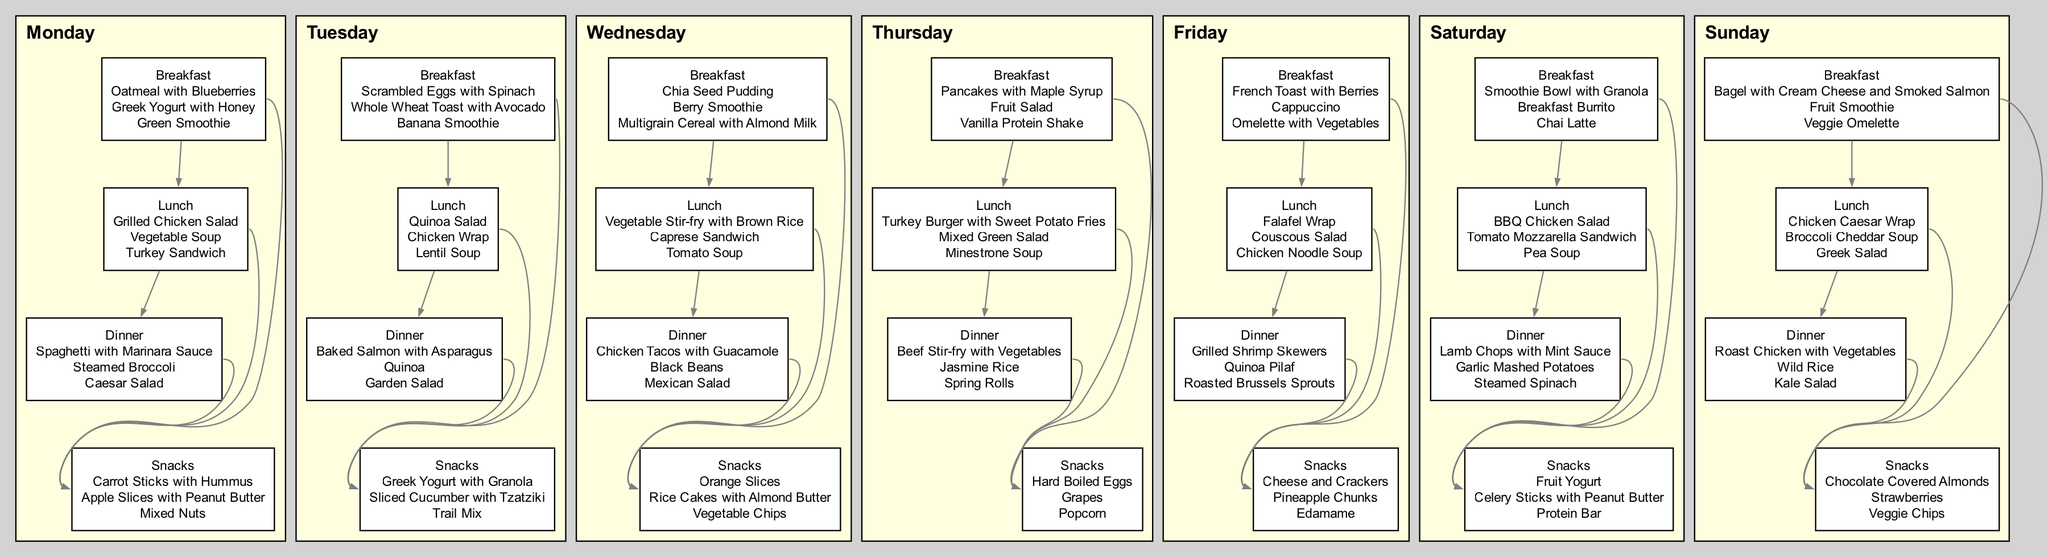What are the snack options for Monday? The node for Monday's Snacks lists "Carrot Sticks with Hummus", "Apple Slices with Peanut Butter", and "Mixed Nuts". Thus, these are the options for snacks on that day.
Answer: Carrot Sticks with Hummus, Apple Slices with Peanut Butter, Mixed Nuts How many types of meals are there shown for each day? The diagram includes four types of meals for every day: Breakfast, Lunch, Dinner, and Snacks. Therefore, there are four meal types depicted in each day's subgraph.
Answer: 4 Which day has the option for "Oatmeal with Blueberries"? The "Oatmeal with Blueberries" is listed under the Breakfast section for Monday. Therefore, Monday is the day for this option.
Answer: Monday How many different meals are offered for lunch on Friday? Friday's Lunch section includes three meal options: "Falafel Wrap", "Couscous Salad", and "Chicken Noodle Soup". There are three distinct meal choices offered.
Answer: 3 Which meal on Wednesday is paired with "Black Beans"? On Wednesday, "Chicken Tacos with Guacamole" is presented in the Dinner section, and "Black Beans" is noted as an additional option. Therefore, the meal paired with "Black Beans" is Dinner on Wednesday.
Answer: Dinner What is the relationship between Thursday's Lunch and Snacks? The relationship is depicted as an edge connecting Thursday's Lunch node to Thursday's Snacks node, indicating that Lunch options link to the Snacks available for that day.
Answer: Lunch to Snacks Which day features a "Smoothie Bowl with Granola"? The "Smoothie Bowl with Granola" is listed under the Breakfast section for Saturday, meaning it is an option for that specific day.
Answer: Saturday How many nodes are there in total for the day of Tuesday? Tuesday's meal sections consist of nodes for Breakfast, Lunch, Dinner, and Snacks. Each category has one node, resulting in a total of four nodes for Tuesday.
Answer: 4 Which meal type connects directly to Wednesday's Snacks? Both Lunch and Dinner nodes connect directly to Wednesday's Snacks. The edges from these meal types indicate this direct connection in the diagram.
Answer: Lunch, Dinner 